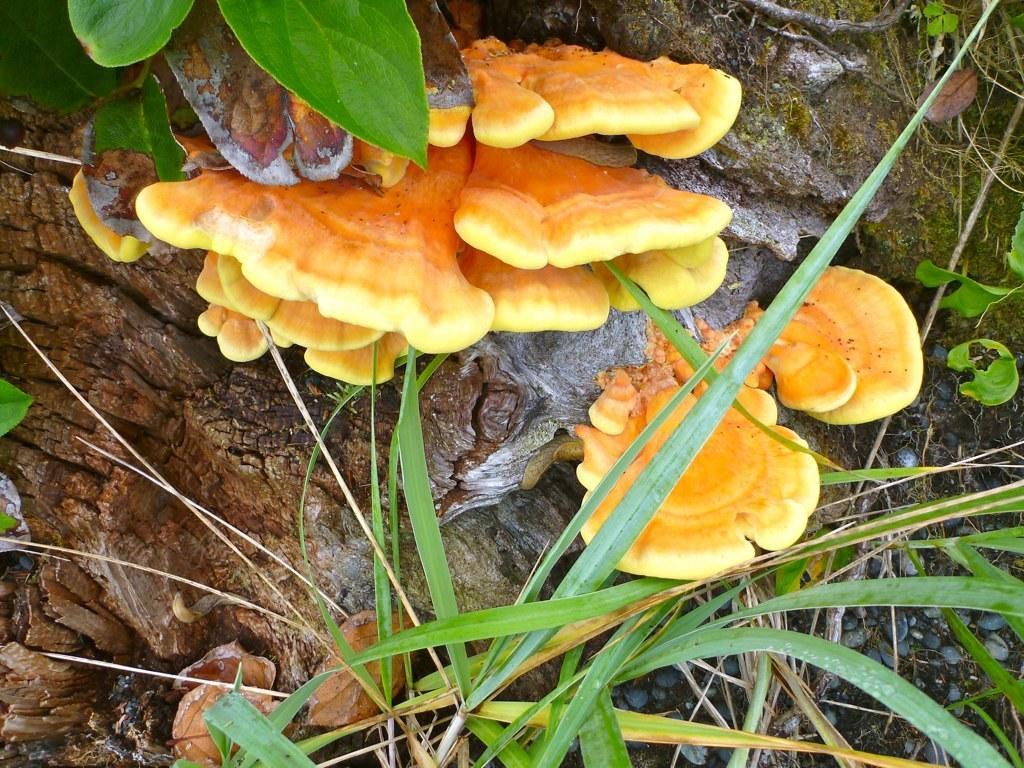How would you summarize this image in a sentence or two? In this picture there is a tree and there are plants and there it looks mushroom. At the bottom there are pebbles and there is mud. 